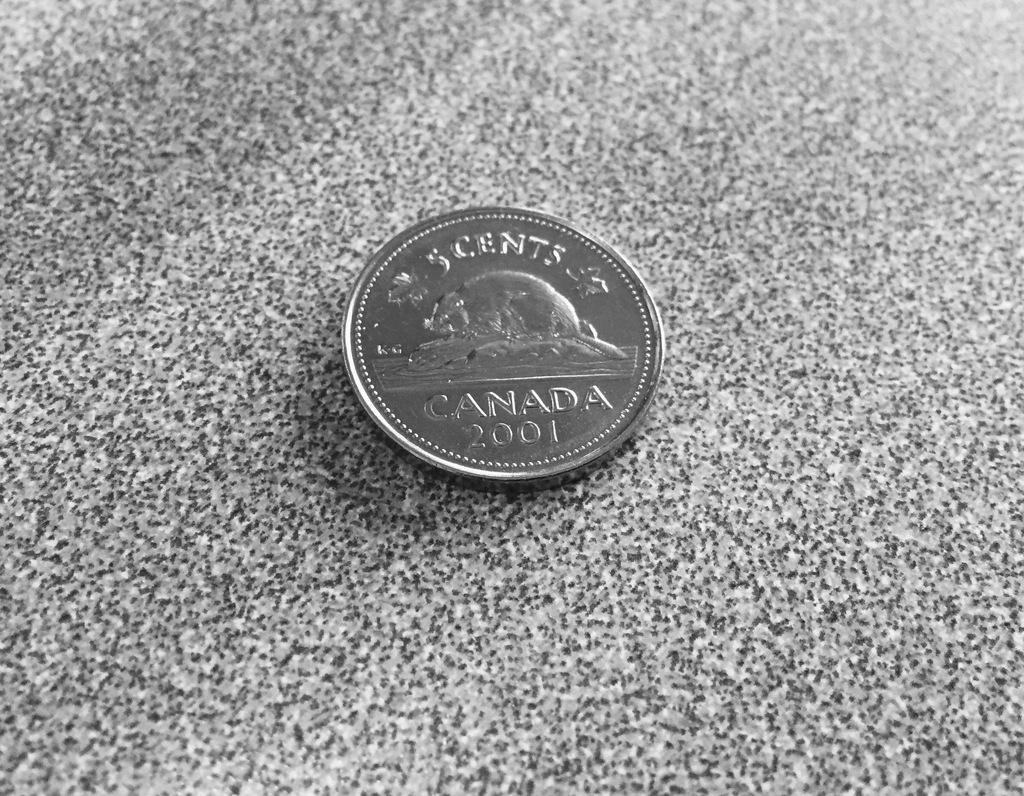Provide a one-sentence caption for the provided image. A five cent Canadian coin with the date 2001 on it. 